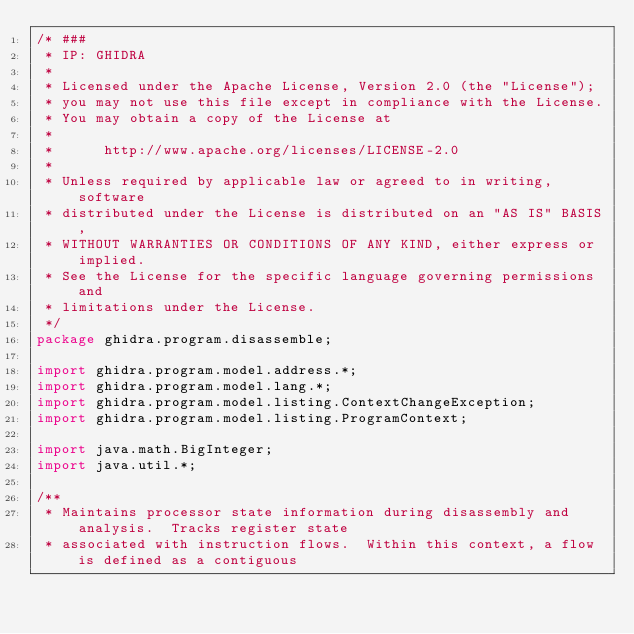Convert code to text. <code><loc_0><loc_0><loc_500><loc_500><_Java_>/* ###
 * IP: GHIDRA
 *
 * Licensed under the Apache License, Version 2.0 (the "License");
 * you may not use this file except in compliance with the License.
 * You may obtain a copy of the License at
 * 
 *      http://www.apache.org/licenses/LICENSE-2.0
 * 
 * Unless required by applicable law or agreed to in writing, software
 * distributed under the License is distributed on an "AS IS" BASIS,
 * WITHOUT WARRANTIES OR CONDITIONS OF ANY KIND, either express or implied.
 * See the License for the specific language governing permissions and
 * limitations under the License.
 */
package ghidra.program.disassemble;

import ghidra.program.model.address.*;
import ghidra.program.model.lang.*;
import ghidra.program.model.listing.ContextChangeException;
import ghidra.program.model.listing.ProgramContext;

import java.math.BigInteger;
import java.util.*;

/**
 * Maintains processor state information during disassembly and analysis.  Tracks register state 
 * associated with instruction flows.  Within this context, a flow is defined as a contiguous</code> 